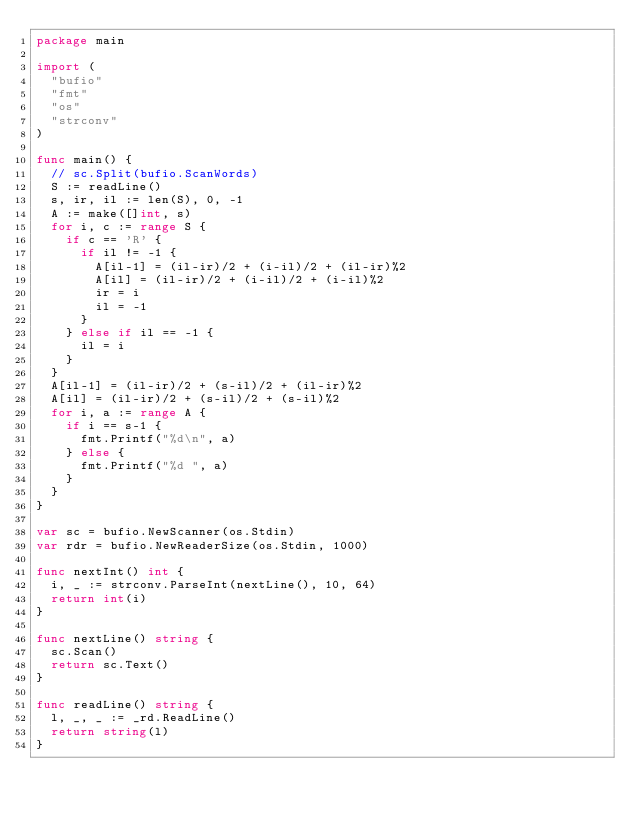<code> <loc_0><loc_0><loc_500><loc_500><_Go_>package main

import (
	"bufio"
	"fmt"
	"os"
	"strconv"
)

func main() {
	// sc.Split(bufio.ScanWords)
	S := readLine()
	s, ir, il := len(S), 0, -1
	A := make([]int, s)
	for i, c := range S {
		if c == 'R' {
			if il != -1 {
				A[il-1] = (il-ir)/2 + (i-il)/2 + (il-ir)%2
				A[il] = (il-ir)/2 + (i-il)/2 + (i-il)%2
				ir = i
				il = -1
			}
		} else if il == -1 {
			il = i
		}
	}
	A[il-1] = (il-ir)/2 + (s-il)/2 + (il-ir)%2
	A[il] = (il-ir)/2 + (s-il)/2 + (s-il)%2
	for i, a := range A {
		if i == s-1 {
			fmt.Printf("%d\n", a)
		} else {
			fmt.Printf("%d ", a)
		}
	}
}

var sc = bufio.NewScanner(os.Stdin)
var rdr = bufio.NewReaderSize(os.Stdin, 1000)

func nextInt() int {
	i, _ := strconv.ParseInt(nextLine(), 10, 64)
	return int(i)
}

func nextLine() string {
	sc.Scan()
	return sc.Text()
}

func readLine() string {
	l, _, _ := _rd.ReadLine()
	return string(l)
}
</code> 